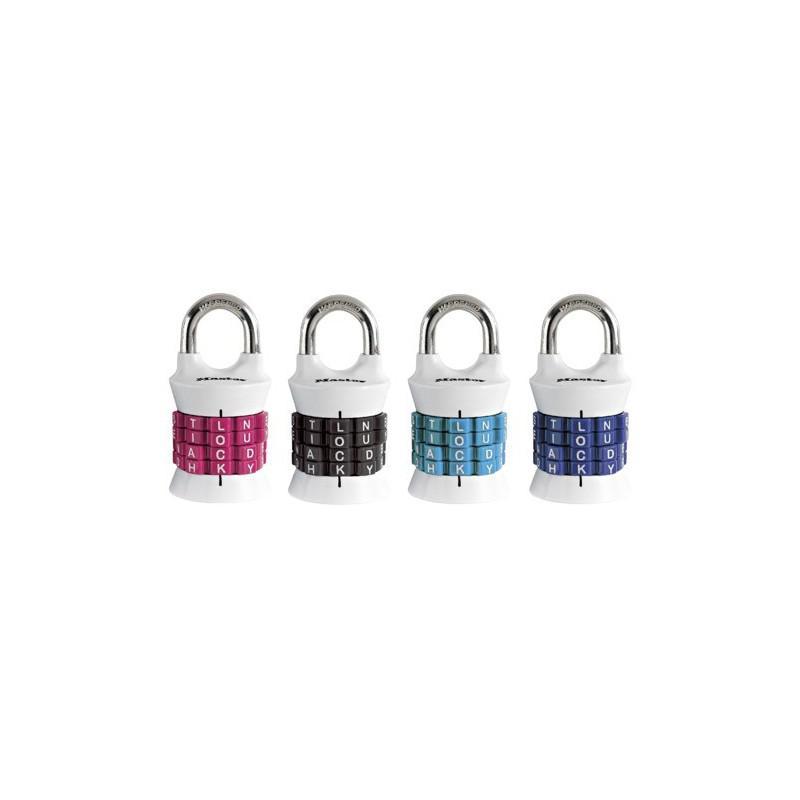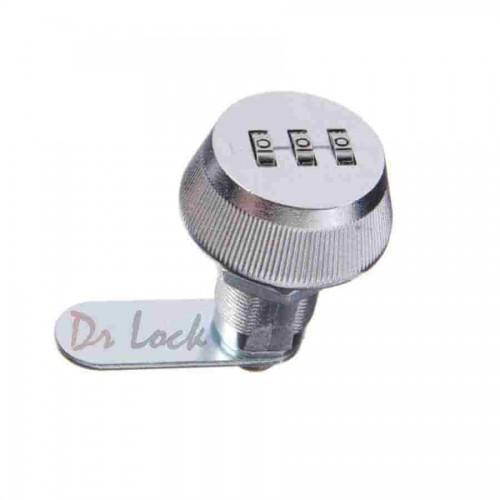The first image is the image on the left, the second image is the image on the right. Analyze the images presented: Is the assertion "Of two locks, one is all metal with sliding number belts on the side, while the other has the number belts in a different position and a white cord lock loop." valid? Answer yes or no. No. The first image is the image on the left, the second image is the image on the right. For the images displayed, is the sentence "The lock in the image on the right is silver metal." factually correct? Answer yes or no. Yes. 